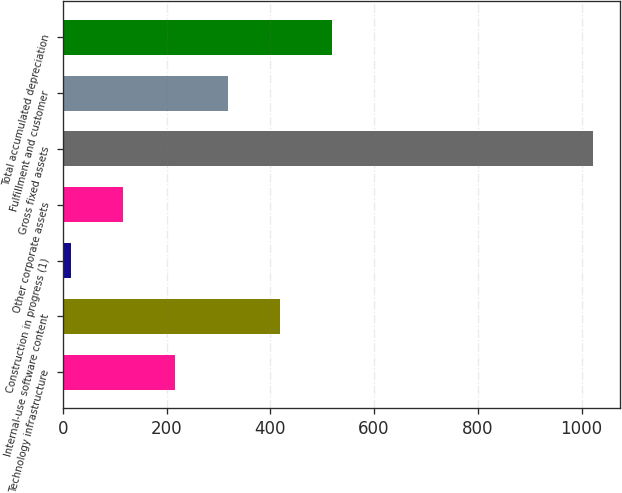Convert chart to OTSL. <chart><loc_0><loc_0><loc_500><loc_500><bar_chart><fcel>Technology infrastructure<fcel>Internal-use software content<fcel>Construction in progress (1)<fcel>Other corporate assets<fcel>Gross fixed assets<fcel>Fulfillment and customer<fcel>Total accumulated depreciation<nl><fcel>216.6<fcel>418.2<fcel>15<fcel>115.8<fcel>1023<fcel>317.4<fcel>519<nl></chart> 